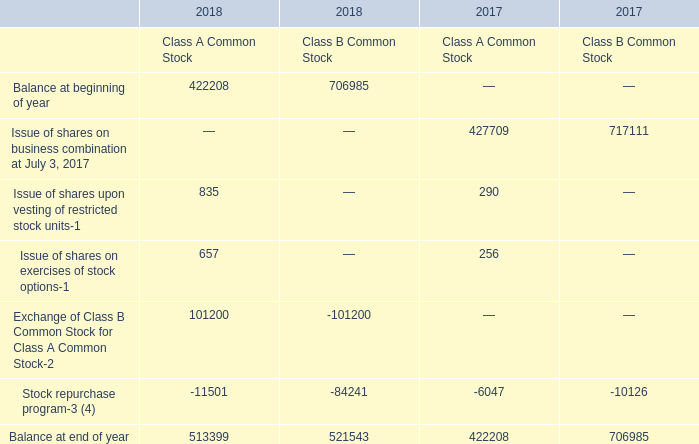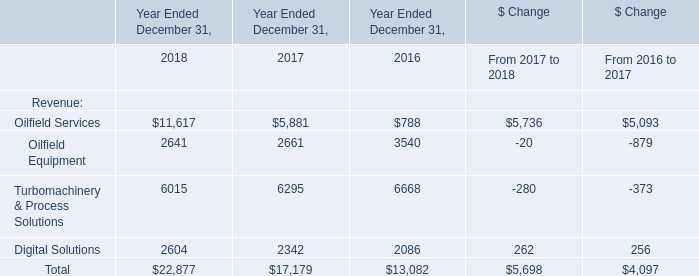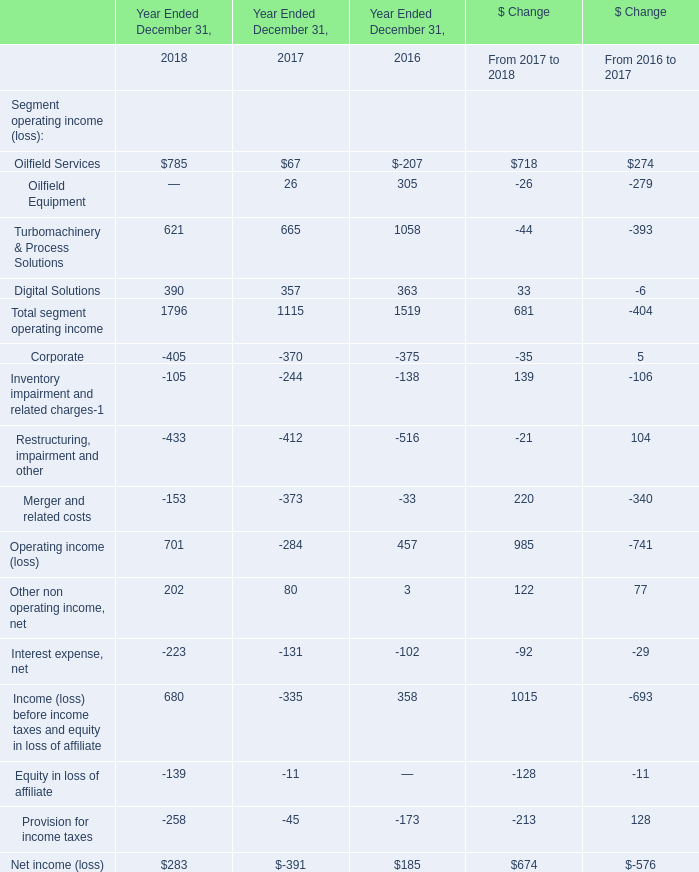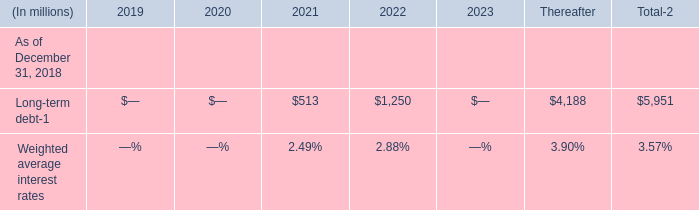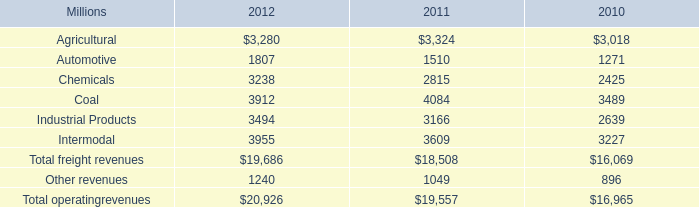What's the total amount of Oilfield Services, Oilfield Equipment ,Turbomachinery & Process Solutionsin and Digital Solutions in 2018? (in million) 
Computations: ((785 + 621) + 390)
Answer: 1796.0. 